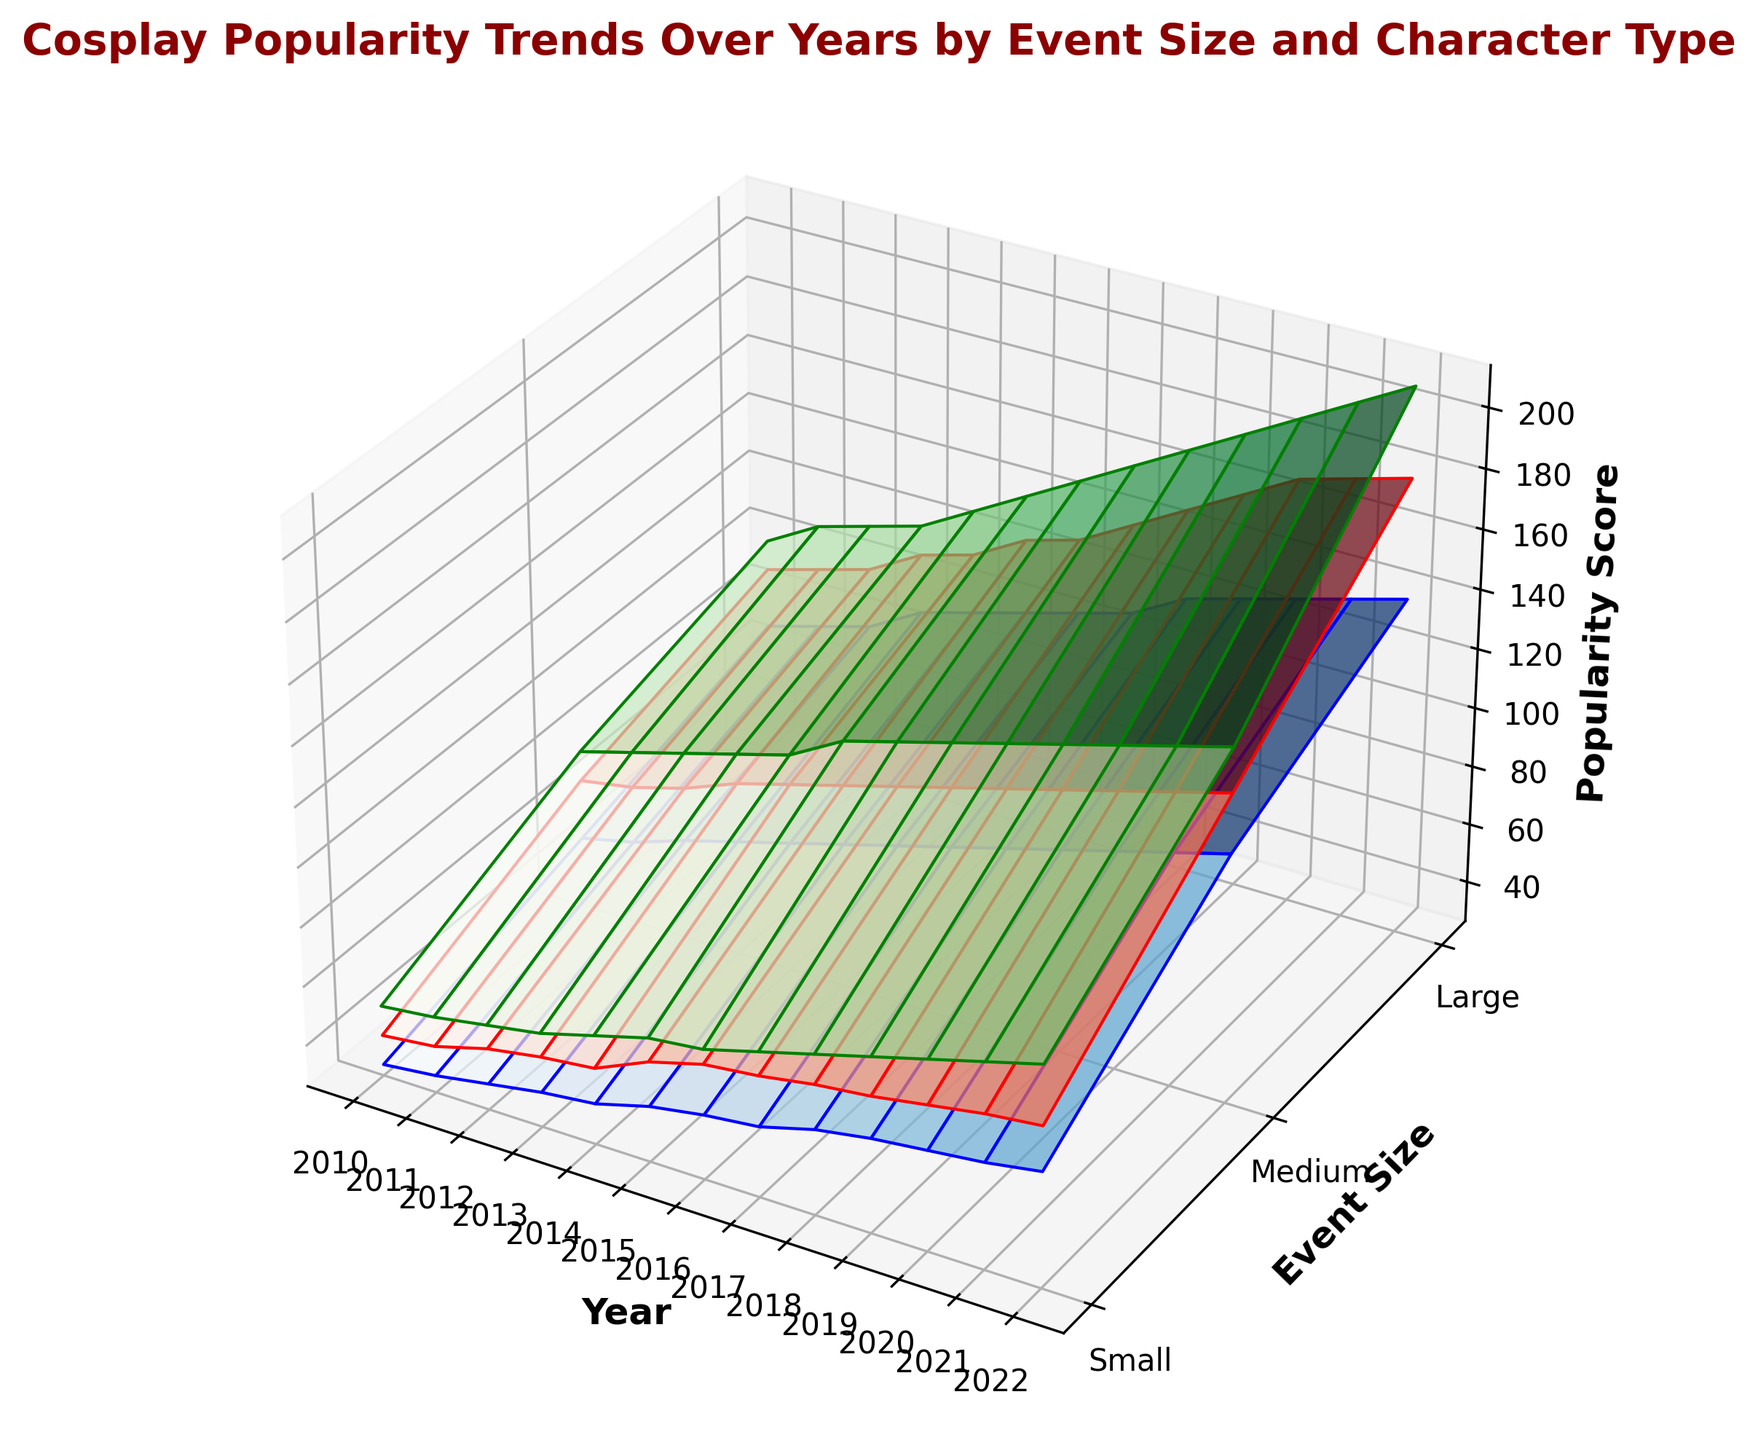What is the trend in the popularity of anime characters at medium-sized events from 2010 to 2022? To find the trend, look at the heights of the blue surface for medium-sized events across the years from 2010 to 2022. The popularity score increases from 50 in 2010 to 110 in 2022. Therefore, anime characters' popularity at medium-sized events increased over this period.
Answer: Increased Which event size had the highest popularity score for movie characters in 2022? To determine the event size with the highest popularity score for movie characters in 2022, observe the green surface in the figure for the year 2022. The highest peak occurs at the "Large" event size.
Answer: Large How does the popularity score for comic characters at small events in 2012 compare to their popularity at medium-sized events in the same year? Check the red surface for comic characters in 2012, comparing the heights for small and medium event sizes. The small event score is 47, and the medium event score is 78.
Answer: 47 (small), 78 (medium) By how much did the popularity score for movie characters at large events increase from 2010 to 2022? Look at the green surface for large events in 2010 and 2022. The popularity score increased from 100 in 2010 to 210 in 2022. Subtract the 2010 value from the 2022 value for the increase: 210 - 100 = 110.
Answer: 110 What is the average popularity score for comic characters at medium events over the 12 years? Find the red surface heights for medium events from 2010 to 2022 and calculate their average. Scores are 70, 73, 78, 85, 90, 95, 100, 105, 110, 115, 120, 125, 130. Sum = 1071, count = 13, so average is 1071 / 13 ≈ 82.38.
Answer: ~82.38 Which character type saw the highest increase in popularity scores at small events from 2010 to 2022? Compare the height differences on the blue, red, and green surfaces for small events between 2010 and 2022. Anime 30 to 65 (35), Comic 40 to 80 (40), Movie 50 to 100 (50). The highest increase is for movie characters.
Answer: Movie In what year did large comic events first surpass a popularity score of 150? Check the height of the red surface for large events each year until you see a score over 150. This first happens in 2018.
Answer: 2018 Which character type and event size combination consistently had the lowest popularity score from 2010 to 2022? Identify the lowest surface height across the years for all combinations. Anime characters at small events always had lower scores compared to others, starting at 30 in 2010.
Answer: Anime, Small What is the difference between the popularity scores of movie and anime characters at large events in 2021? Look at the green and blue surfaces for large events in 2021. Movie score is 200, and Anime score is 135. Subtract the anime score from the movie score: 200 - 135 = 65.
Answer: 65 How did the popularity score for comic characters at small events change from 2010 to 2015? Examine the red surface for small events between 2010 and 2015. The score increased from 40 in 2010 to 60 in 2015. Change is 60 - 40 = 20.
Answer: Increased by 20 